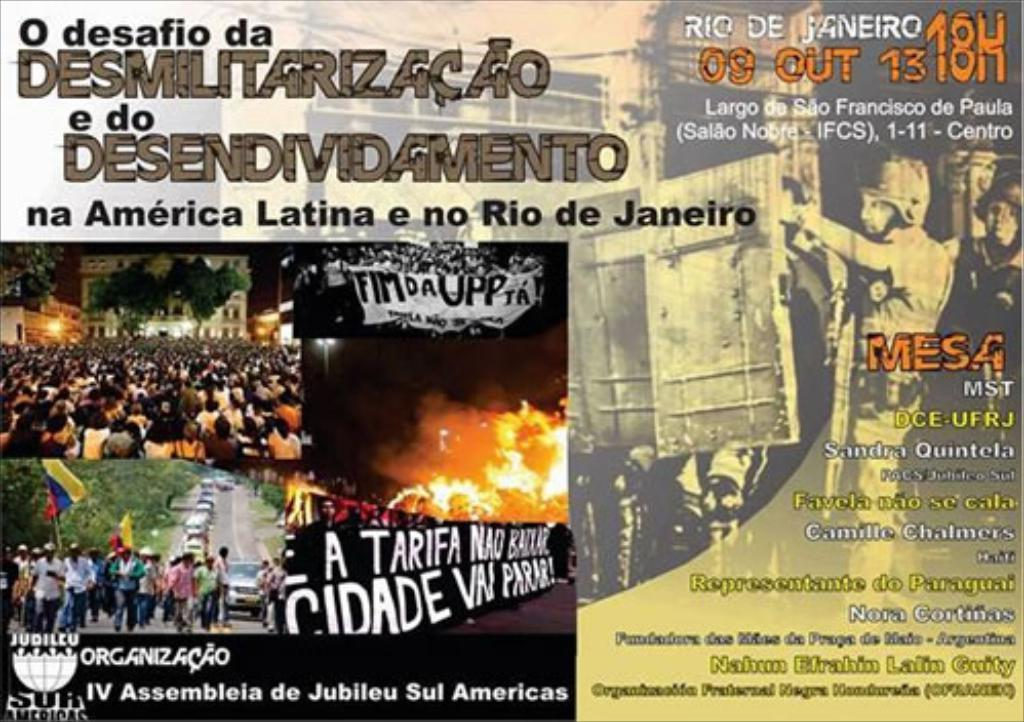<image>
Summarize the visual content of the image. A poster has the words Rio De Janeiro in the corner. 